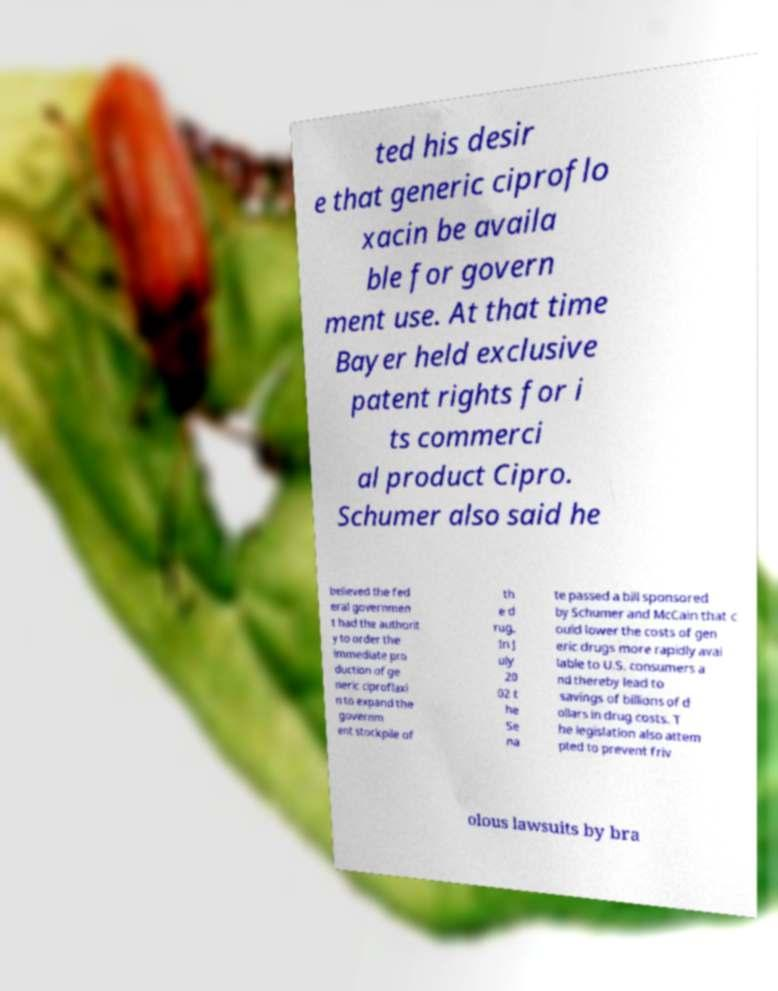For documentation purposes, I need the text within this image transcribed. Could you provide that? ted his desir e that generic ciproflo xacin be availa ble for govern ment use. At that time Bayer held exclusive patent rights for i ts commerci al product Cipro. Schumer also said he believed the fed eral governmen t had the authorit y to order the immediate pro duction of ge neric ciproflaxi n to expand the governm ent stockpile of th e d rug. In J uly 20 02 t he Se na te passed a bill sponsored by Schumer and McCain that c ould lower the costs of gen eric drugs more rapidly avai lable to U.S. consumers a nd thereby lead to savings of billions of d ollars in drug costs. T he legislation also attem pted to prevent friv olous lawsuits by bra 